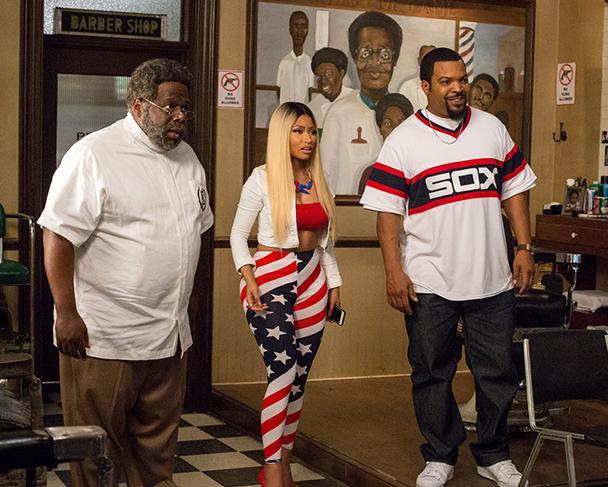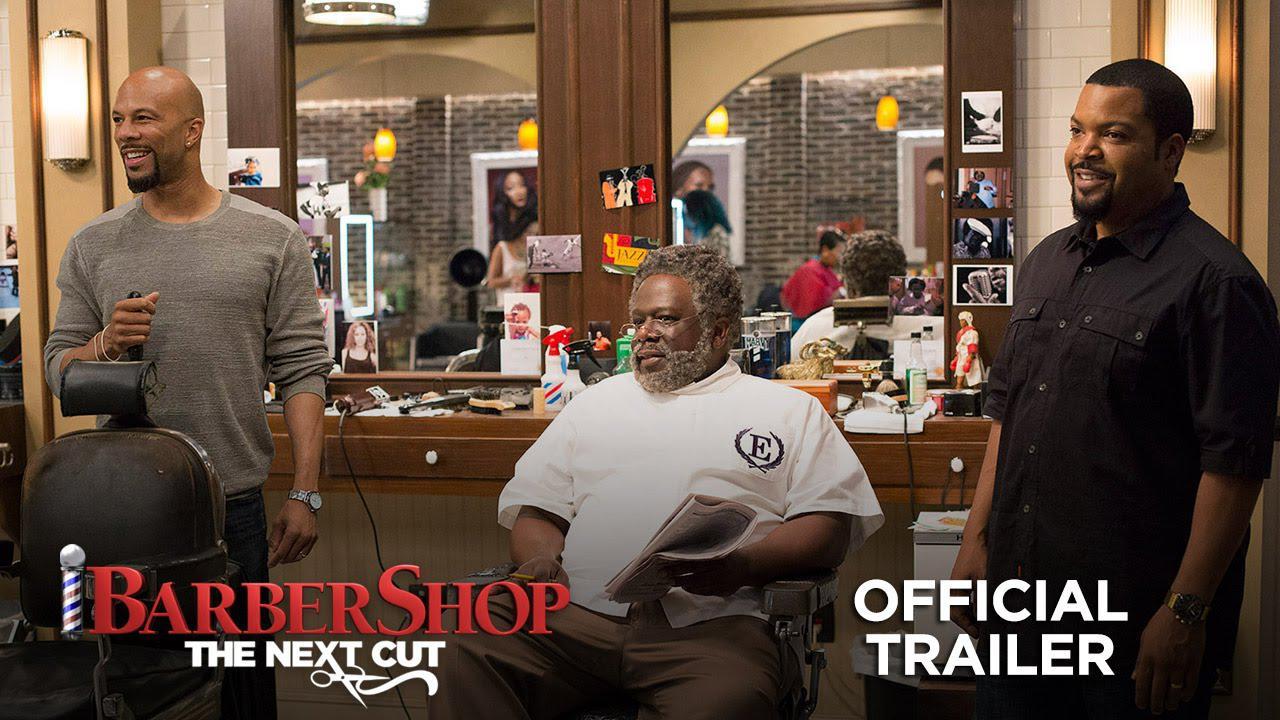The first image is the image on the left, the second image is the image on the right. Assess this claim about the two images: "An image includes a woman wearing red top and stars-and-stripes bottoms.". Correct or not? Answer yes or no. Yes. The first image is the image on the left, the second image is the image on the right. Evaluate the accuracy of this statement regarding the images: "In one image, a large barber shop mural is on a back wall beside a door.". Is it true? Answer yes or no. Yes. 